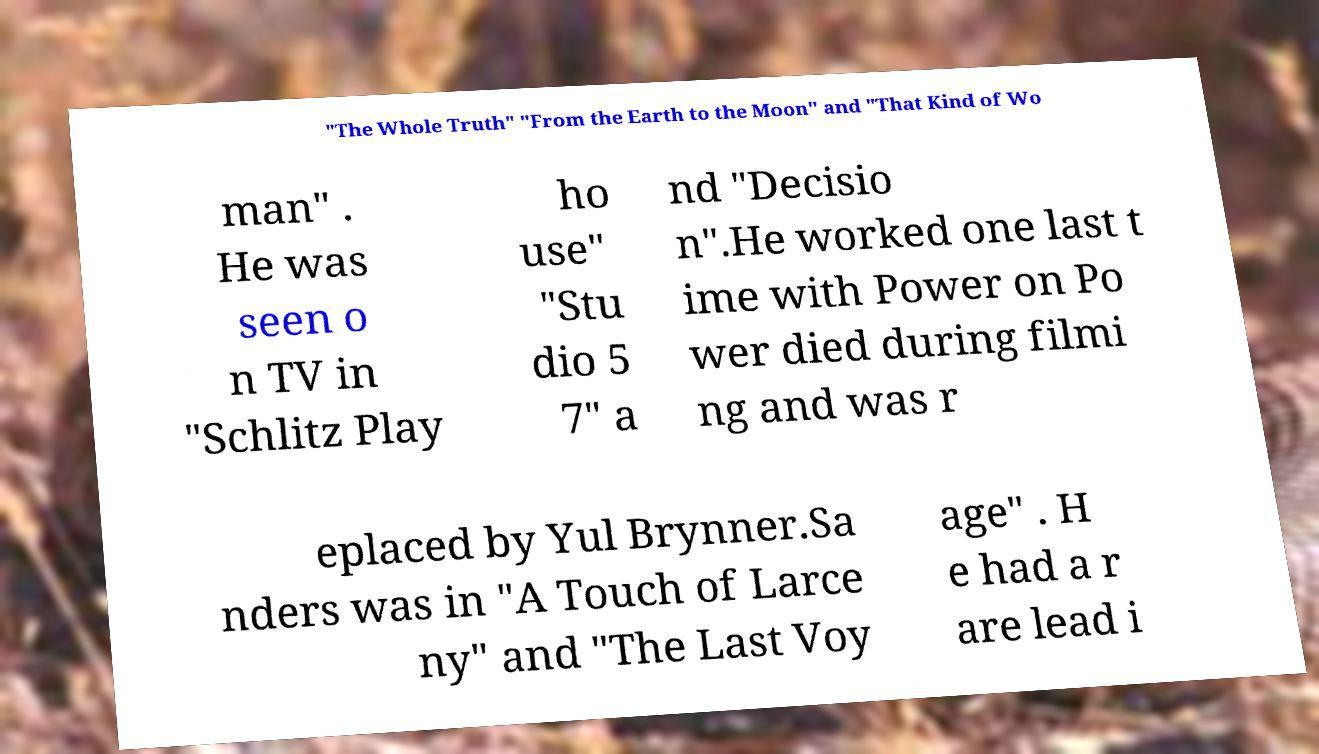What messages or text are displayed in this image? I need them in a readable, typed format. "The Whole Truth" "From the Earth to the Moon" and "That Kind of Wo man" . He was seen o n TV in "Schlitz Play ho use" "Stu dio 5 7" a nd "Decisio n".He worked one last t ime with Power on Po wer died during filmi ng and was r eplaced by Yul Brynner.Sa nders was in "A Touch of Larce ny" and "The Last Voy age" . H e had a r are lead i 